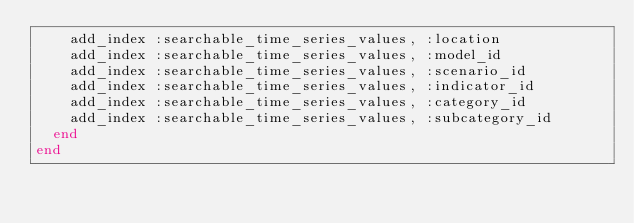<code> <loc_0><loc_0><loc_500><loc_500><_Ruby_>    add_index :searchable_time_series_values, :location
    add_index :searchable_time_series_values, :model_id
    add_index :searchable_time_series_values, :scenario_id
    add_index :searchable_time_series_values, :indicator_id
    add_index :searchable_time_series_values, :category_id
    add_index :searchable_time_series_values, :subcategory_id
  end
end
</code> 